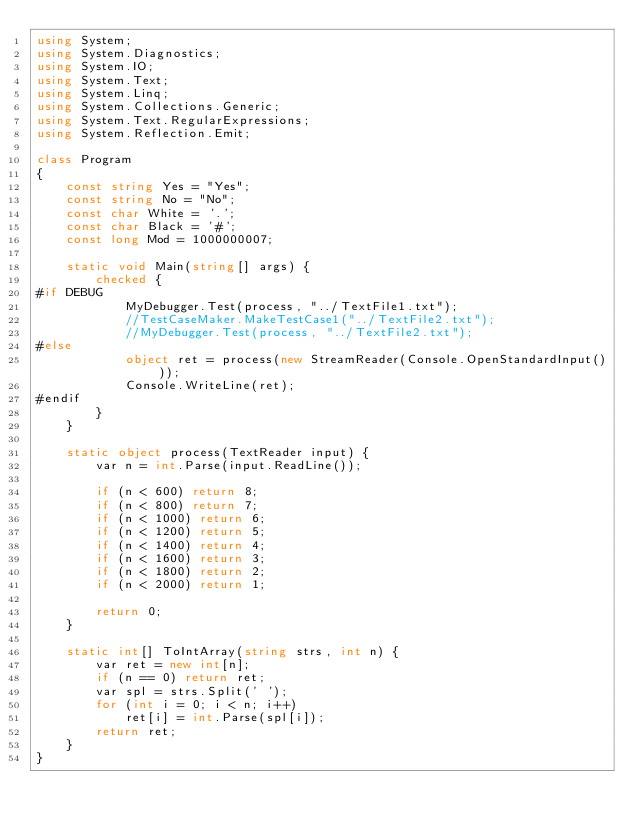Convert code to text. <code><loc_0><loc_0><loc_500><loc_500><_C#_>using System;
using System.Diagnostics;
using System.IO;
using System.Text;
using System.Linq;
using System.Collections.Generic;
using System.Text.RegularExpressions;
using System.Reflection.Emit;

class Program
{
    const string Yes = "Yes";
    const string No = "No";
    const char White = '.';
    const char Black = '#';
    const long Mod = 1000000007;

    static void Main(string[] args) {
        checked {
#if DEBUG
            MyDebugger.Test(process, "../TextFile1.txt");
            //TestCaseMaker.MakeTestCase1("../TextFile2.txt");
            //MyDebugger.Test(process, "../TextFile2.txt");
#else
            object ret = process(new StreamReader(Console.OpenStandardInput()));
            Console.WriteLine(ret);
#endif
        }
    }

    static object process(TextReader input) {
        var n = int.Parse(input.ReadLine());

        if (n < 600) return 8;
        if (n < 800) return 7;
        if (n < 1000) return 6;
        if (n < 1200) return 5;
        if (n < 1400) return 4;
        if (n < 1600) return 3;
        if (n < 1800) return 2;
        if (n < 2000) return 1;

        return 0;
    }

    static int[] ToIntArray(string strs, int n) {
        var ret = new int[n];
        if (n == 0) return ret;
        var spl = strs.Split(' ');
        for (int i = 0; i < n; i++)
            ret[i] = int.Parse(spl[i]);
        return ret;
    }
}
</code> 